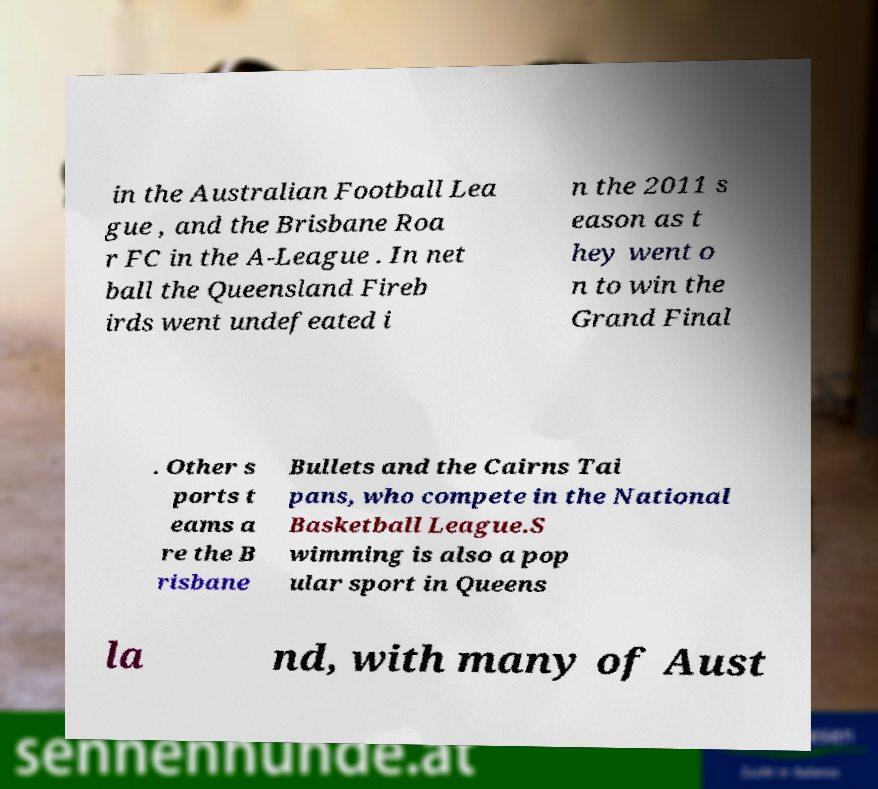There's text embedded in this image that I need extracted. Can you transcribe it verbatim? in the Australian Football Lea gue , and the Brisbane Roa r FC in the A-League . In net ball the Queensland Fireb irds went undefeated i n the 2011 s eason as t hey went o n to win the Grand Final . Other s ports t eams a re the B risbane Bullets and the Cairns Tai pans, who compete in the National Basketball League.S wimming is also a pop ular sport in Queens la nd, with many of Aust 